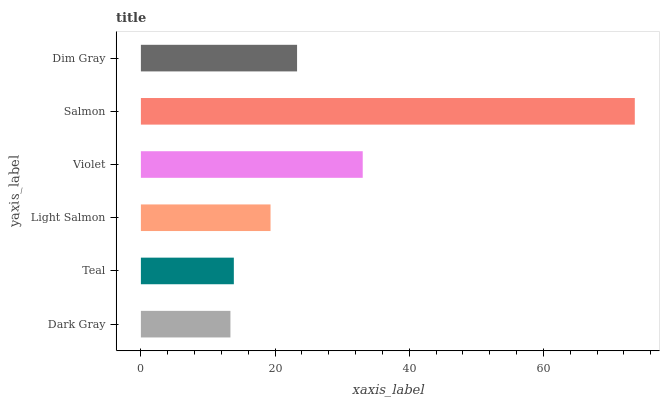Is Dark Gray the minimum?
Answer yes or no. Yes. Is Salmon the maximum?
Answer yes or no. Yes. Is Teal the minimum?
Answer yes or no. No. Is Teal the maximum?
Answer yes or no. No. Is Teal greater than Dark Gray?
Answer yes or no. Yes. Is Dark Gray less than Teal?
Answer yes or no. Yes. Is Dark Gray greater than Teal?
Answer yes or no. No. Is Teal less than Dark Gray?
Answer yes or no. No. Is Dim Gray the high median?
Answer yes or no. Yes. Is Light Salmon the low median?
Answer yes or no. Yes. Is Violet the high median?
Answer yes or no. No. Is Dim Gray the low median?
Answer yes or no. No. 